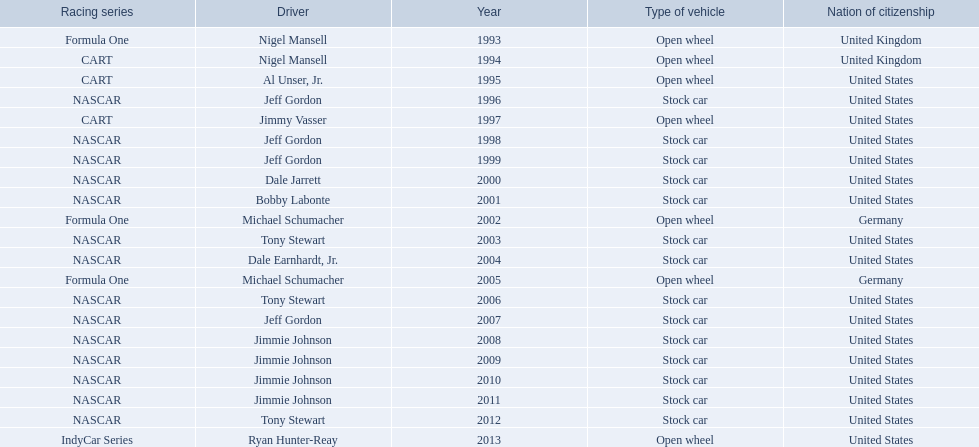Who won an espy in the year 2004, bobby labonte, tony stewart, dale earnhardt jr., or jeff gordon? Dale Earnhardt, Jr. Who won the espy in the year 1997; nigel mansell, al unser, jr., jeff gordon, or jimmy vasser? Jimmy Vasser. Which one only has one espy; nigel mansell, al unser jr., michael schumacher, or jeff gordon? Al Unser, Jr. 